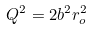<formula> <loc_0><loc_0><loc_500><loc_500>Q ^ { 2 } = 2 b ^ { 2 } r _ { o } ^ { 2 }</formula> 